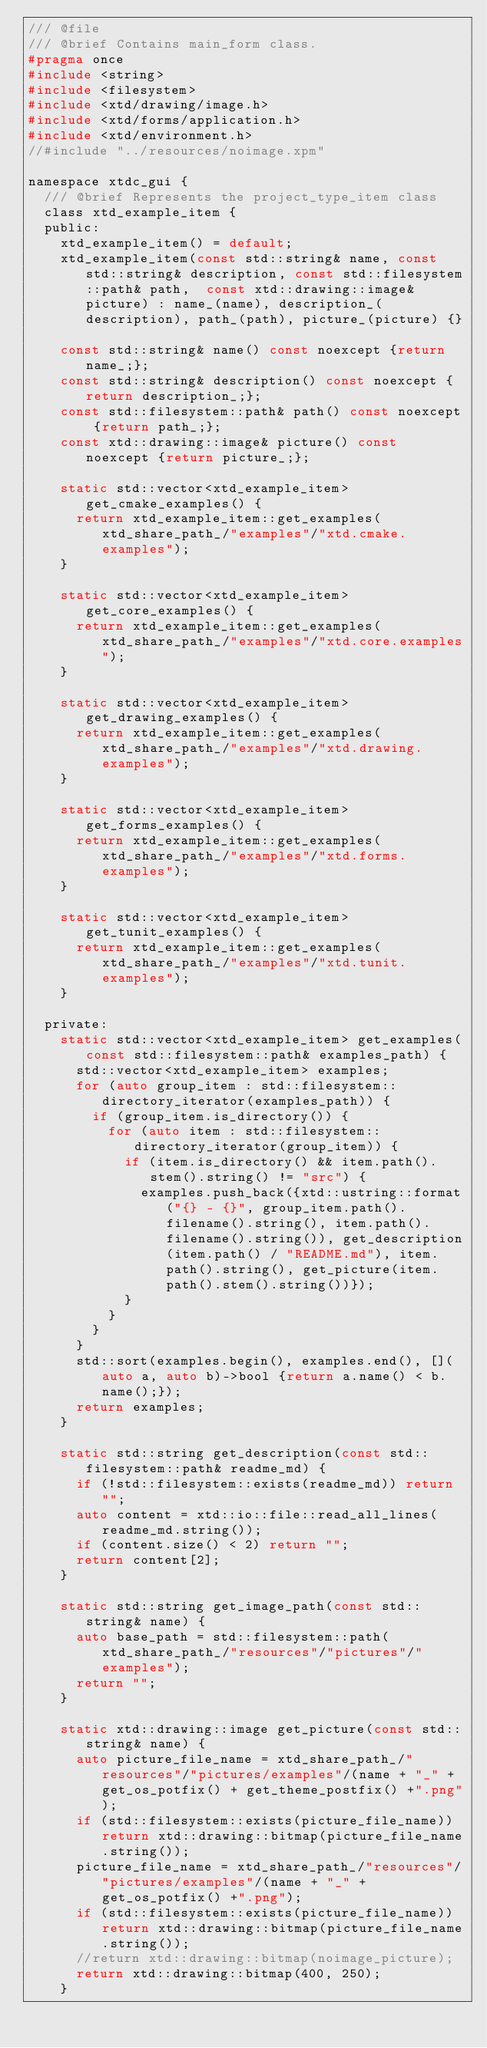Convert code to text. <code><loc_0><loc_0><loc_500><loc_500><_C_>/// @file
/// @brief Contains main_form class.
#pragma once
#include <string>
#include <filesystem>
#include <xtd/drawing/image.h>
#include <xtd/forms/application.h>
#include <xtd/environment.h>
//#include "../resources/noimage.xpm"

namespace xtdc_gui {
  /// @brief Represents the project_type_item class
  class xtd_example_item {
  public:
    xtd_example_item() = default;
    xtd_example_item(const std::string& name, const std::string& description, const std::filesystem::path& path,  const xtd::drawing::image& picture) : name_(name), description_(description), path_(path), picture_(picture) {}
    
    const std::string& name() const noexcept {return name_;};
    const std::string& description() const noexcept {return description_;};
    const std::filesystem::path& path() const noexcept {return path_;};
    const xtd::drawing::image& picture() const noexcept {return picture_;};
    
    static std::vector<xtd_example_item> get_cmake_examples() {
      return xtd_example_item::get_examples(xtd_share_path_/"examples"/"xtd.cmake.examples");
    }
    
    static std::vector<xtd_example_item> get_core_examples() {
      return xtd_example_item::get_examples(xtd_share_path_/"examples"/"xtd.core.examples");
    }
    
    static std::vector<xtd_example_item> get_drawing_examples() {
      return xtd_example_item::get_examples(xtd_share_path_/"examples"/"xtd.drawing.examples");
    }
    
    static std::vector<xtd_example_item> get_forms_examples() {
      return xtd_example_item::get_examples(xtd_share_path_/"examples"/"xtd.forms.examples");
    }
    
    static std::vector<xtd_example_item> get_tunit_examples() {
      return xtd_example_item::get_examples(xtd_share_path_/"examples"/"xtd.tunit.examples");
    }
    
  private:
    static std::vector<xtd_example_item> get_examples(const std::filesystem::path& examples_path) {
      std::vector<xtd_example_item> examples;
      for (auto group_item : std::filesystem::directory_iterator(examples_path)) {
        if (group_item.is_directory()) {
          for (auto item : std::filesystem::directory_iterator(group_item)) {
            if (item.is_directory() && item.path().stem().string() != "src") {
              examples.push_back({xtd::ustring::format("{} - {}", group_item.path().filename().string(), item.path().filename().string()), get_description(item.path() / "README.md"), item.path().string(), get_picture(item.path().stem().string())});
            }
          }
        }
      }
      std::sort(examples.begin(), examples.end(), [](auto a, auto b)->bool {return a.name() < b.name();});
      return examples;
    }
    
    static std::string get_description(const std::filesystem::path& readme_md) {
      if (!std::filesystem::exists(readme_md)) return "";
      auto content = xtd::io::file::read_all_lines(readme_md.string());
      if (content.size() < 2) return "";
      return content[2];
    }
    
    static std::string get_image_path(const std::string& name) {
      auto base_path = std::filesystem::path(xtd_share_path_/"resources"/"pictures"/"examples");
      return "";
    }
    
    static xtd::drawing::image get_picture(const std::string& name) {
      auto picture_file_name = xtd_share_path_/"resources"/"pictures/examples"/(name + "_" + get_os_potfix() + get_theme_postfix() +".png");
      if (std::filesystem::exists(picture_file_name)) return xtd::drawing::bitmap(picture_file_name.string());
      picture_file_name = xtd_share_path_/"resources"/"pictures/examples"/(name + "_" + get_os_potfix() +".png");
      if (std::filesystem::exists(picture_file_name)) return xtd::drawing::bitmap(picture_file_name.string());
      //return xtd::drawing::bitmap(noimage_picture);
      return xtd::drawing::bitmap(400, 250);
    }
    </code> 